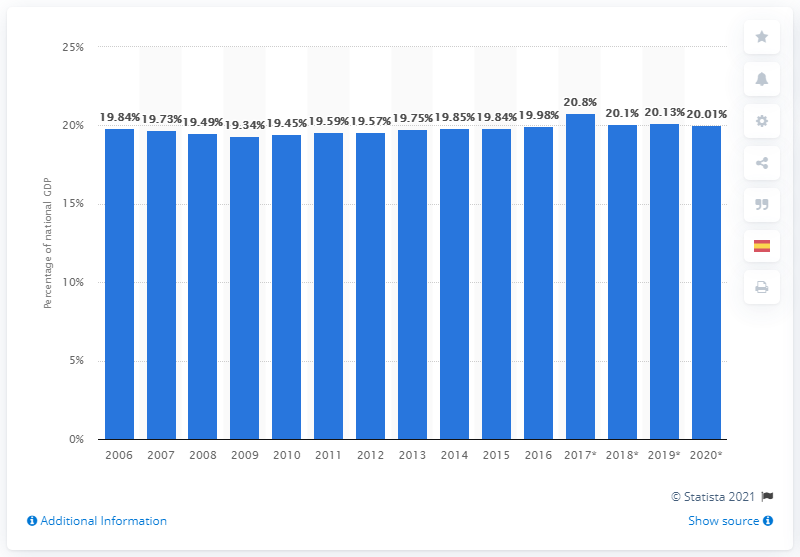Mention a couple of crucial points in this snapshot. According to available data, Catalonia's share of Spain's GDP was projected to be 20.01% by 2020. 